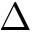<formula> <loc_0><loc_0><loc_500><loc_500>\Delta</formula> 